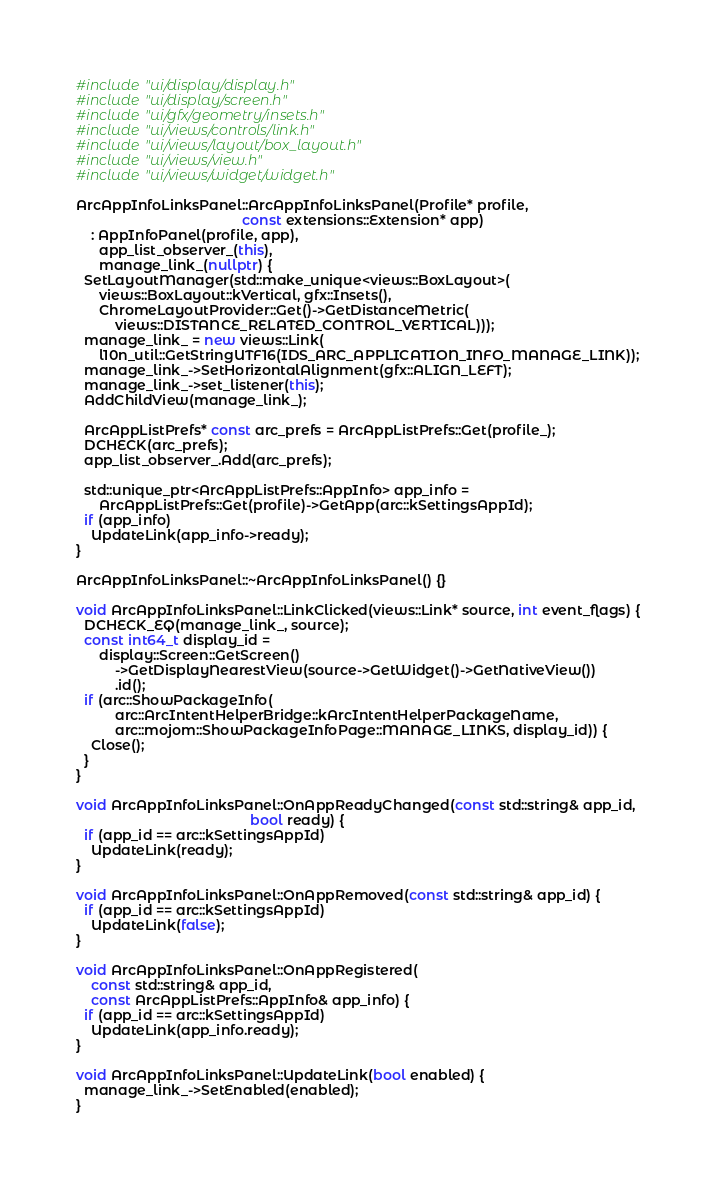Convert code to text. <code><loc_0><loc_0><loc_500><loc_500><_C++_>#include "ui/display/display.h"
#include "ui/display/screen.h"
#include "ui/gfx/geometry/insets.h"
#include "ui/views/controls/link.h"
#include "ui/views/layout/box_layout.h"
#include "ui/views/view.h"
#include "ui/views/widget/widget.h"

ArcAppInfoLinksPanel::ArcAppInfoLinksPanel(Profile* profile,
                                           const extensions::Extension* app)
    : AppInfoPanel(profile, app),
      app_list_observer_(this),
      manage_link_(nullptr) {
  SetLayoutManager(std::make_unique<views::BoxLayout>(
      views::BoxLayout::kVertical, gfx::Insets(),
      ChromeLayoutProvider::Get()->GetDistanceMetric(
          views::DISTANCE_RELATED_CONTROL_VERTICAL)));
  manage_link_ = new views::Link(
      l10n_util::GetStringUTF16(IDS_ARC_APPLICATION_INFO_MANAGE_LINK));
  manage_link_->SetHorizontalAlignment(gfx::ALIGN_LEFT);
  manage_link_->set_listener(this);
  AddChildView(manage_link_);

  ArcAppListPrefs* const arc_prefs = ArcAppListPrefs::Get(profile_);
  DCHECK(arc_prefs);
  app_list_observer_.Add(arc_prefs);

  std::unique_ptr<ArcAppListPrefs::AppInfo> app_info =
      ArcAppListPrefs::Get(profile)->GetApp(arc::kSettingsAppId);
  if (app_info)
    UpdateLink(app_info->ready);
}

ArcAppInfoLinksPanel::~ArcAppInfoLinksPanel() {}

void ArcAppInfoLinksPanel::LinkClicked(views::Link* source, int event_flags) {
  DCHECK_EQ(manage_link_, source);
  const int64_t display_id =
      display::Screen::GetScreen()
          ->GetDisplayNearestView(source->GetWidget()->GetNativeView())
          .id();
  if (arc::ShowPackageInfo(
          arc::ArcIntentHelperBridge::kArcIntentHelperPackageName,
          arc::mojom::ShowPackageInfoPage::MANAGE_LINKS, display_id)) {
    Close();
  }
}

void ArcAppInfoLinksPanel::OnAppReadyChanged(const std::string& app_id,
                                             bool ready) {
  if (app_id == arc::kSettingsAppId)
    UpdateLink(ready);
}

void ArcAppInfoLinksPanel::OnAppRemoved(const std::string& app_id) {
  if (app_id == arc::kSettingsAppId)
    UpdateLink(false);
}

void ArcAppInfoLinksPanel::OnAppRegistered(
    const std::string& app_id,
    const ArcAppListPrefs::AppInfo& app_info) {
  if (app_id == arc::kSettingsAppId)
    UpdateLink(app_info.ready);
}

void ArcAppInfoLinksPanel::UpdateLink(bool enabled) {
  manage_link_->SetEnabled(enabled);
}
</code> 